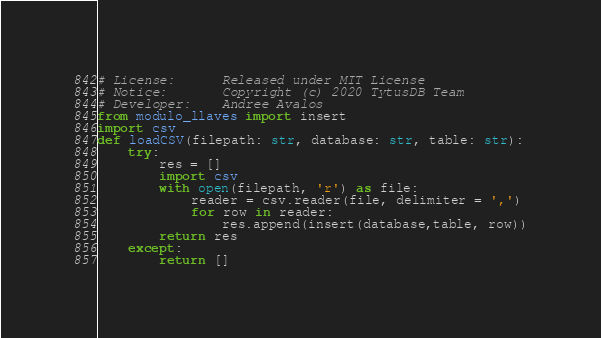<code> <loc_0><loc_0><loc_500><loc_500><_Python_># License:      Released under MIT License
# Notice:       Copyright (c) 2020 TytusDB Team
# Developer:    Andree Avalos
from modulo_llaves import insert
import csv
def loadCSV(filepath: str, database: str, table: str):
    try:
        res = []
        import csv
        with open(filepath, 'r') as file:
            reader = csv.reader(file, delimiter = ',')
            for row in reader:
                res.append(insert(database,table, row))
        return res
    except:
        return []
</code> 